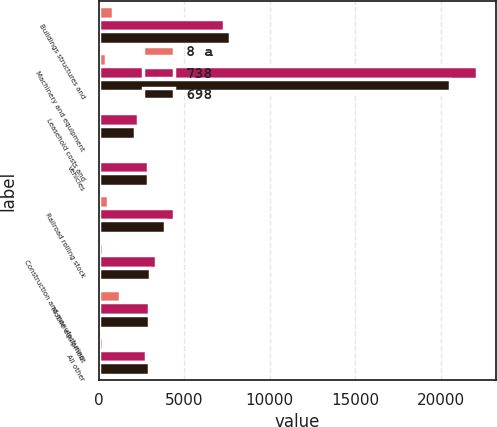Convert chart. <chart><loc_0><loc_0><loc_500><loc_500><stacked_bar_chart><ecel><fcel>Buildings structures and<fcel>Machinery and equipment<fcel>Leasehold costs and<fcel>Vehicles<fcel>Railroad rolling stock<fcel>Construction and manufacturing<fcel>Mobile equipment<fcel>All other<nl><fcel>8 a<fcel>840<fcel>420<fcel>110<fcel>114<fcel>536<fcel>225<fcel>1225<fcel>240<nl><fcel>738<fcel>7354<fcel>22114<fcel>2305<fcel>2871.5<fcel>4402<fcel>3363<fcel>2954<fcel>2789<nl><fcel>698<fcel>7700<fcel>20569<fcel>2121<fcel>2871.5<fcel>3866<fcel>3031<fcel>2964<fcel>2961<nl></chart> 